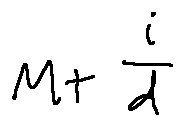Convert formula to latex. <formula><loc_0><loc_0><loc_500><loc_500>M + \frac { i } { d }</formula> 